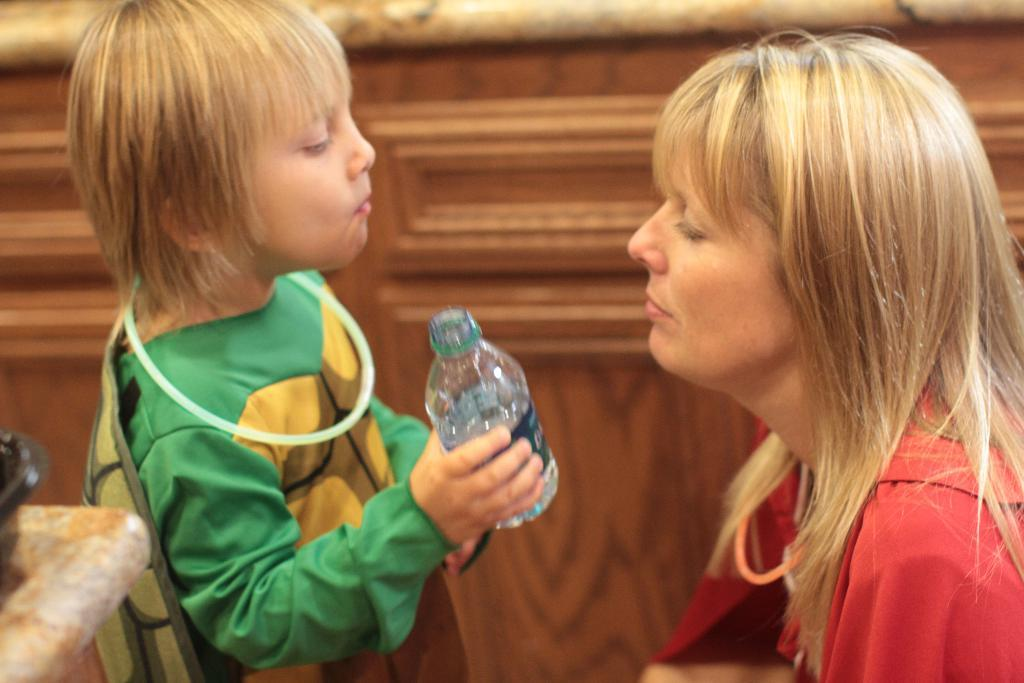Who is present in the image? There is a lady and a boy in the image. What is the lady wearing? The lady is wearing a red shirt. What is the boy wearing? The boy is wearing a green shirt. What object is the boy holding? The boy is holding a water bottle. How many kittens are sitting on the calculator in the image? There is no calculator or kittens present in the image. What type of breath is visible in the image? There is no breath visible in the image. 